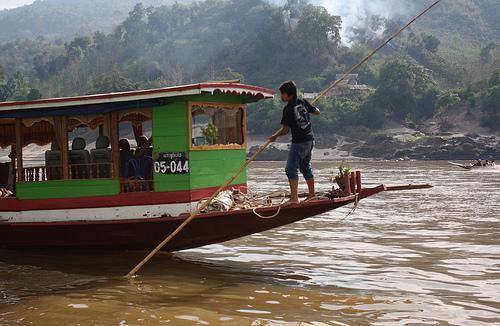How many boats are visible?
Give a very brief answer. 2. 